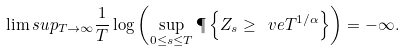<formula> <loc_0><loc_0><loc_500><loc_500>\lim s u p _ { T \to \infty } \frac { 1 } { T } \log \left ( \sup _ { 0 \leq s \leq T } \P \left \{ Z _ { s } \geq \ v e T ^ { 1 / \alpha } \right \} \right ) = - \infty .</formula> 